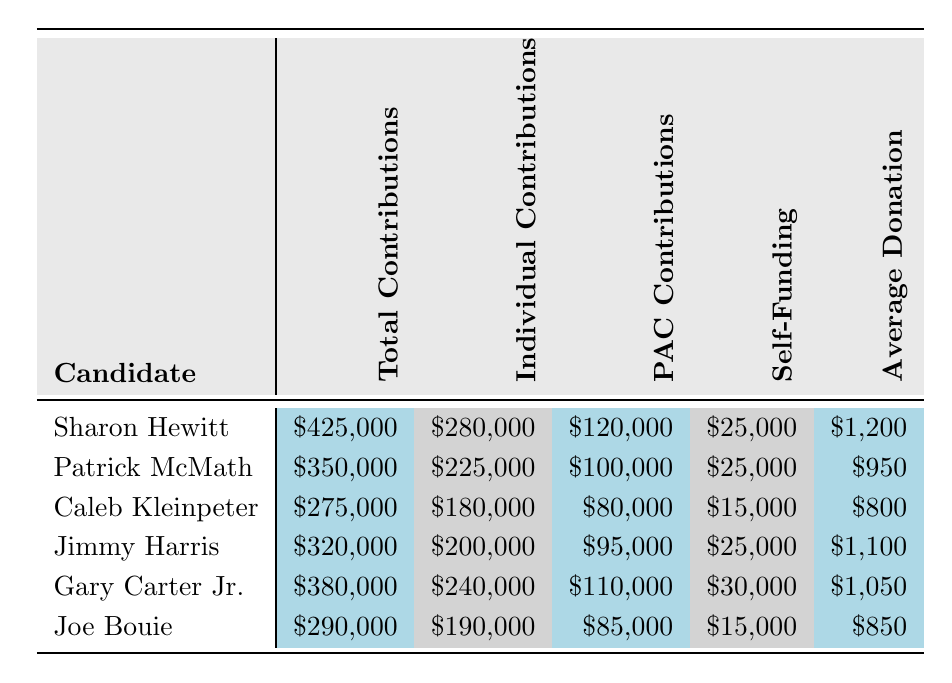What is the total contribution amount for Sharon Hewitt? According to the table, Sharon Hewitt has a total contribution amount of $425,000 listed under the "Total Contributions" column.
Answer: $425,000 Who received the most PAC contributions? By inspecting the "PAC Contributions" column, I see that Sharon Hewitt has the highest amount, which is $120,000.
Answer: Sharon Hewitt What is the average donation received by Gary Carter Jr.? The table shows that Gary Carter Jr. has an "Average Donation" of $1,050. This is the value provided directly in the relevant column.
Answer: $1,050 What is the total of individual contributions for Joe Bouie and Caleb Kleinpeter? To find the total, I add Joe Bouie's individual contributions ($190,000) and Caleb Kleinpeter's individual contributions ($180,000): $190,000 + $180,000 = $370,000.
Answer: $370,000 Did any candidate self-fund more than $30,000? By checking the "Self-Funding" column, I see that only Gary Carter Jr. self-funded $30,000 and no candidates have more than that. Thus, the answer is no.
Answer: No Which candidate had the highest total contributions, and by how much did they exceed the candidate with the second-highest total? Sharon Hewitt had the highest total contributions of $425,000, while Gary Carter Jr. had the second-highest at $380,000. The difference is $425,000 - $380,000 = $45,000.
Answer: Sharon Hewitt, $45,000 What is the median value of total contributions from all candidates? The total contributions sorted are: $275,000, $290,000, $320,000, $350,000, $380,000, $425,000. The median is the average of the two middle values ($320,000 + $350,000)/2 which equals $335,000.
Answer: $335,000 How much more did Patrick McMath collect in individual contributions compared to Joe Bouie? Patrick McMath collected $225,000 in individual contributions, while Joe Bouie collected $190,000. The difference is $225,000 - $190,000 = $35,000.
Answer: $35,000 Which candidate had the lowest average donation and what was the amount? Looking at the "Average Donation" column, Joe Bouie has the lowest average at $850.
Answer: Joe Bouie, $850 How much total funding (sum of total contributions, self-funding, and PAC contributions) did Jimmy Harris receive? Jimmy Harris had total contributions of $320,000, PAC contributions of $95,000, and self-funding of $25,000. The total funding is $320,000 + $95,000 + $25,000 = $440,000.
Answer: $440,000 